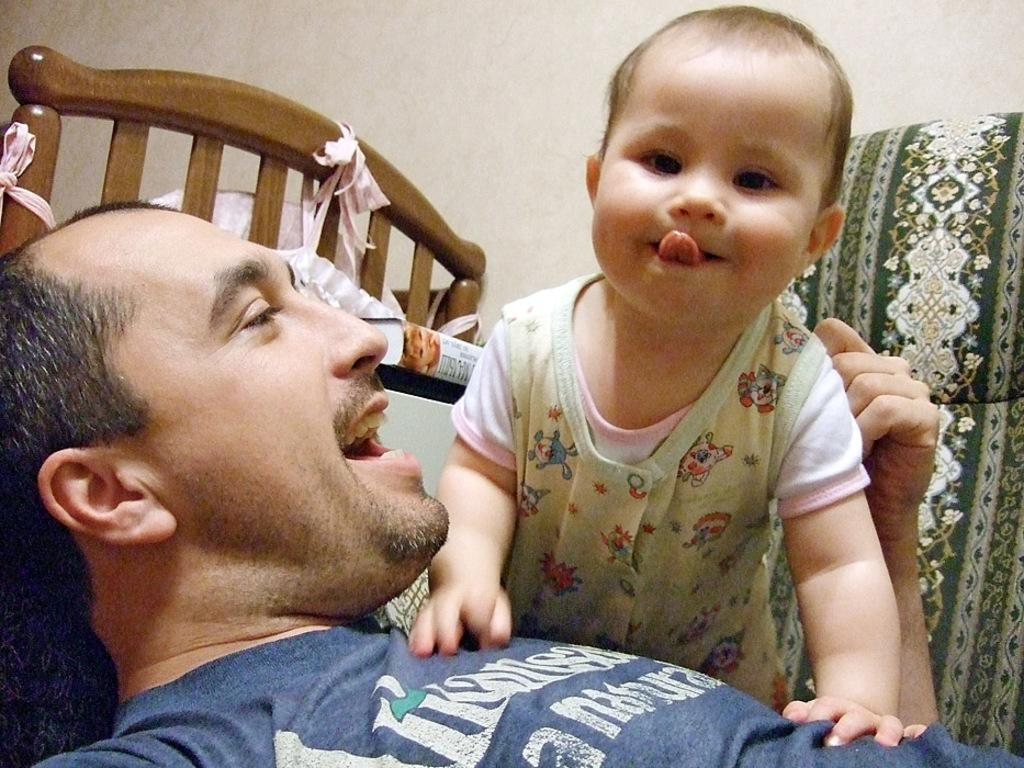Who is present in the image? There is a man and a kid in the image. What are they doing in the image? Both the man and the kid are on a bed. What can be seen in the background of the image? There is a wall in the background of the image. What type of crime is being committed in the image? There is no crime being committed in the image; it simply shows a man and a kid on a bed. Can you recite a verse that is present in the image? There are no verses present in the image; it only features a man, a kid, and a bed. 